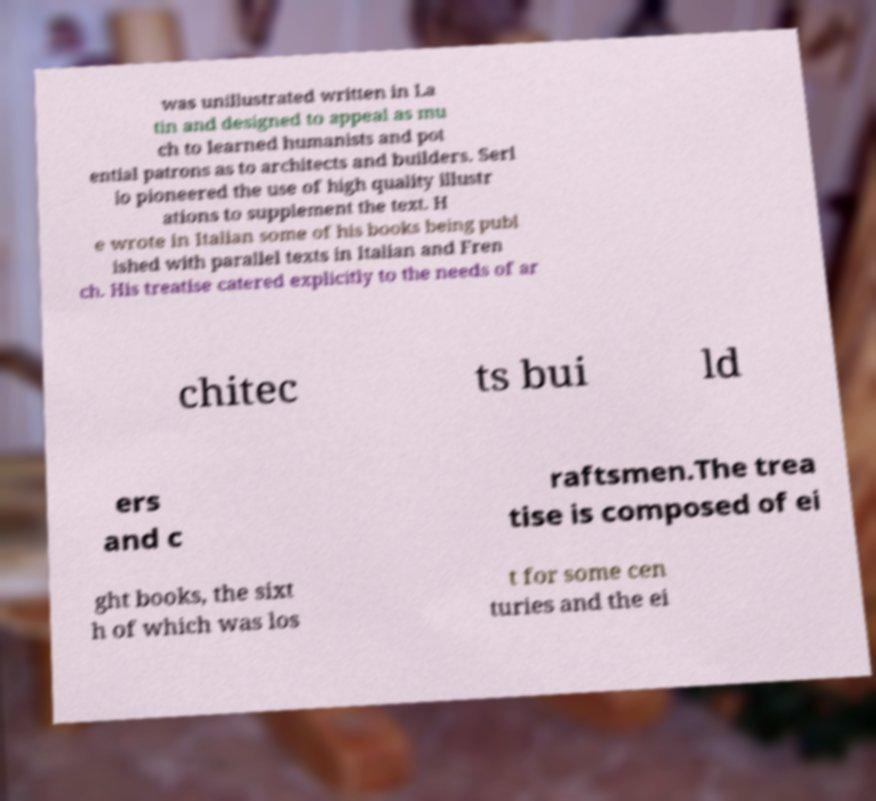Could you assist in decoding the text presented in this image and type it out clearly? was unillustrated written in La tin and designed to appeal as mu ch to learned humanists and pot ential patrons as to architects and builders. Serl io pioneered the use of high quality illustr ations to supplement the text. H e wrote in Italian some of his books being publ ished with parallel texts in Italian and Fren ch. His treatise catered explicitly to the needs of ar chitec ts bui ld ers and c raftsmen.The trea tise is composed of ei ght books, the sixt h of which was los t for some cen turies and the ei 